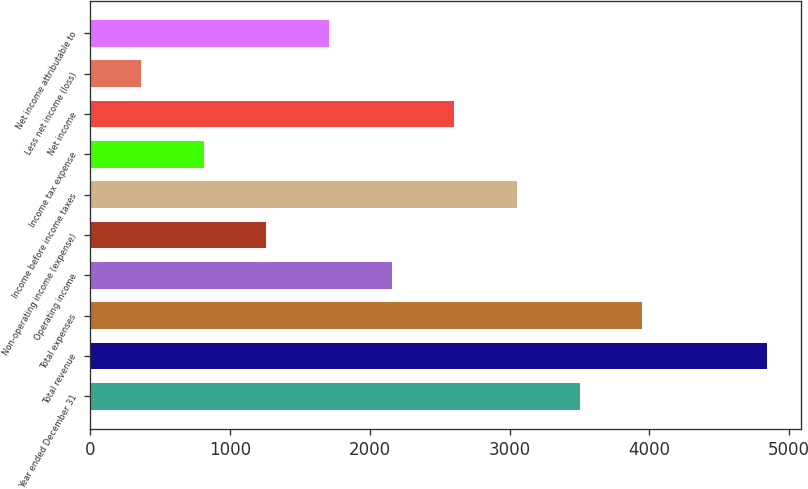Convert chart to OTSL. <chart><loc_0><loc_0><loc_500><loc_500><bar_chart><fcel>Year ended December 31<fcel>Total revenue<fcel>Total expenses<fcel>Operating income<fcel>Non-operating income (expense)<fcel>Income before income taxes<fcel>Income tax expense<fcel>Net income<fcel>Less net income (loss)<fcel>Net income attributable to<nl><fcel>3500.7<fcel>4845<fcel>3948.8<fcel>2156.4<fcel>1260.2<fcel>3052.6<fcel>812.1<fcel>2604.5<fcel>364<fcel>1708.3<nl></chart> 